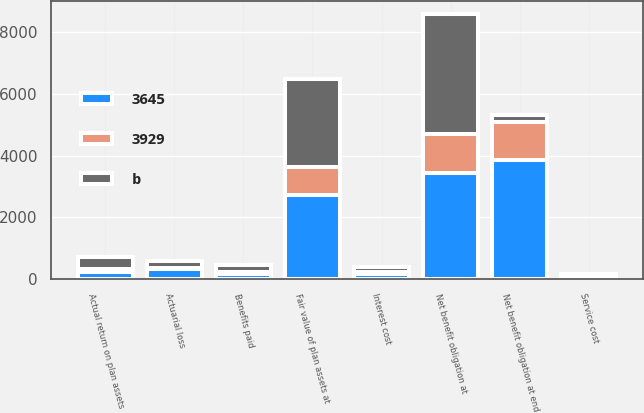<chart> <loc_0><loc_0><loc_500><loc_500><stacked_bar_chart><ecel><fcel>Net benefit obligation at<fcel>Service cost<fcel>Interest cost<fcel>Actuarial loss<fcel>Benefits paid<fcel>Net benefit obligation at end<fcel>Fair value of plan assets at<fcel>Actual return on plan assets<nl><fcel>b<fcel>3865<fcel>83<fcel>170<fcel>246<fcel>209<fcel>224<fcel>2876<fcel>392<nl><fcel>3929<fcel>1257<fcel>24<fcel>52<fcel>5<fcel>73<fcel>1211<fcel>896<fcel>110<nl><fcel>3645<fcel>3451<fcel>75<fcel>180<fcel>348<fcel>173<fcel>3865<fcel>2722<fcel>224<nl></chart> 